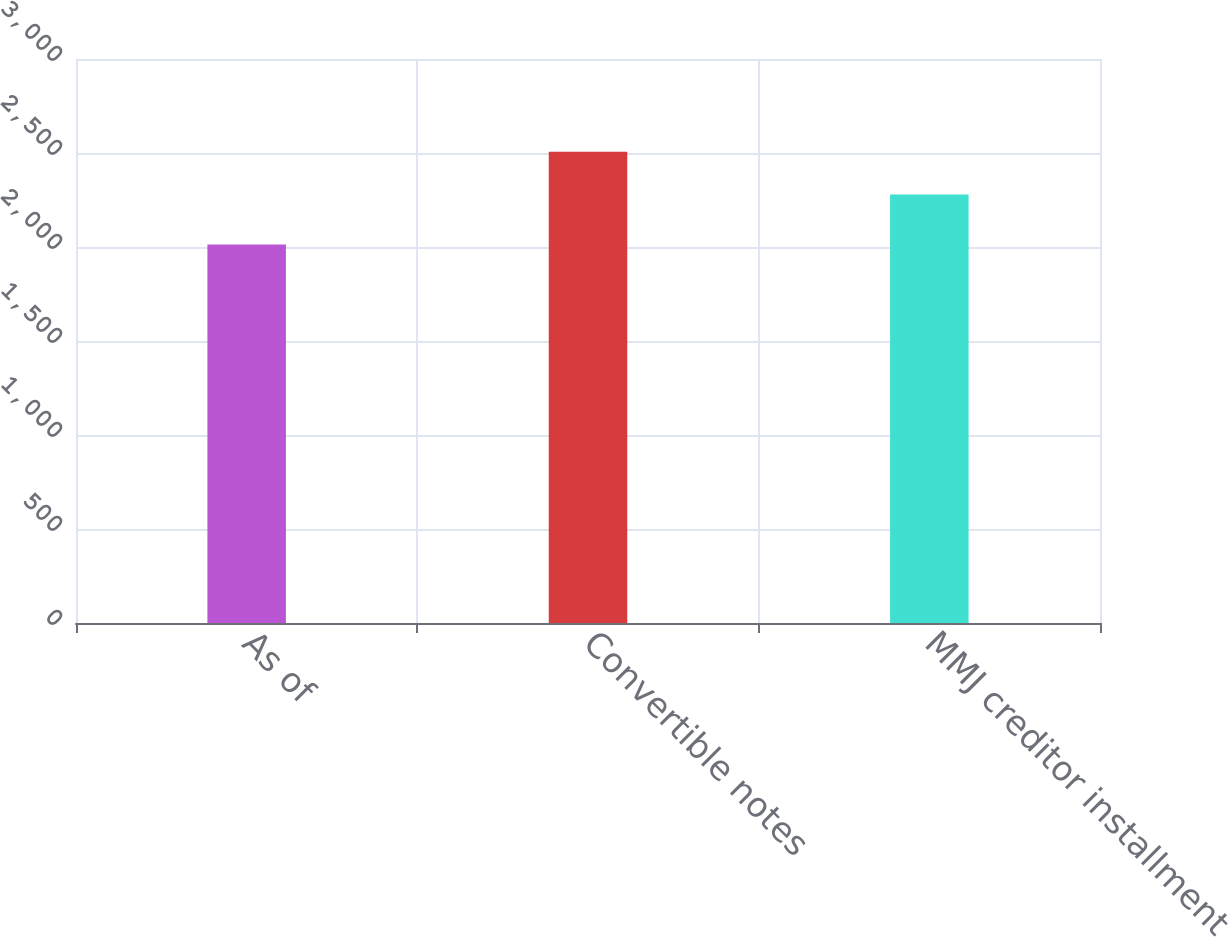Convert chart. <chart><loc_0><loc_0><loc_500><loc_500><bar_chart><fcel>As of<fcel>Convertible notes<fcel>MMJ creditor installment<nl><fcel>2013<fcel>2506<fcel>2279<nl></chart> 